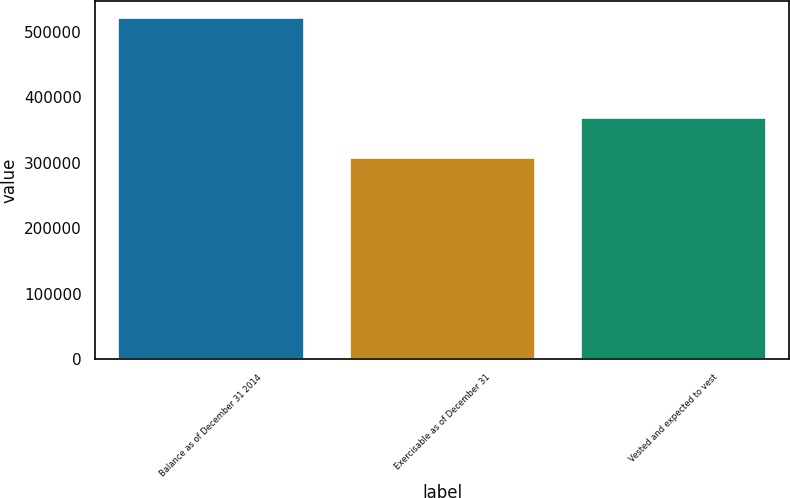Convert chart. <chart><loc_0><loc_0><loc_500><loc_500><bar_chart><fcel>Balance as of December 31 2014<fcel>Exercisable as of December 31<fcel>Vested and expected to vest<nl><fcel>520360<fcel>306808<fcel>368851<nl></chart> 